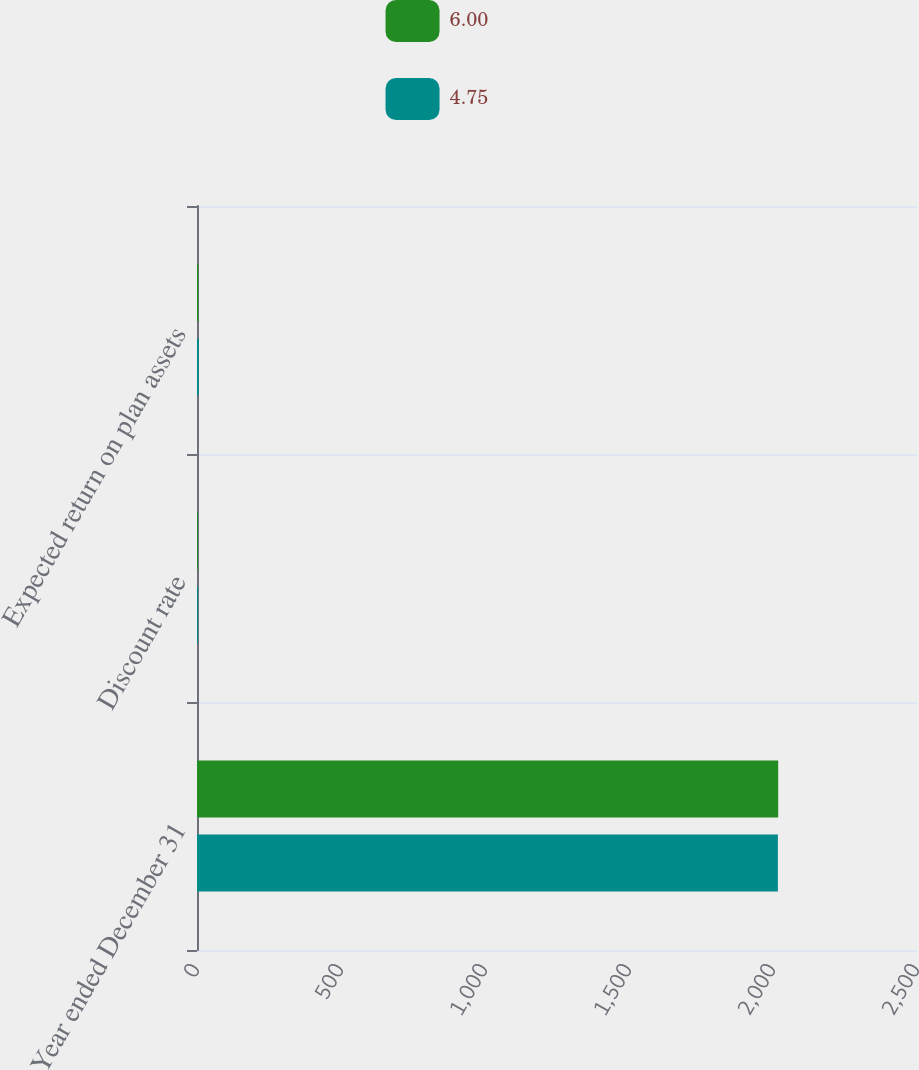Convert chart. <chart><loc_0><loc_0><loc_500><loc_500><stacked_bar_chart><ecel><fcel>Year ended December 31<fcel>Discount rate<fcel>Expected return on plan assets<nl><fcel>6<fcel>2018<fcel>3.25<fcel>4.75<nl><fcel>4.75<fcel>2017<fcel>3.75<fcel>6<nl></chart> 